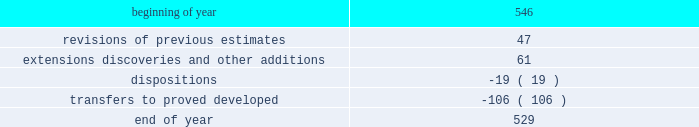Supplementary information on oil and gas producing activities ( unaudited ) 2018 proved reserves decreased by 168 mmboe primarily due to the following : 2022 revisions of previous estimates : increased by 84 mmboe including an increase of 108 mmboe associated with the acceleration of higher economic wells in the u.s .
Resource plays into the 5-year plan and an increase of 15 mmboe associated with wells to sales that were additions to the plan , partially offset by a decrease of 39 mmboe due to technical revisions across the business .
2022 extensions , discoveries , and other additions : increased by 102 mmboe primarily in the u.s .
Resource plays due to an increase of 69 mmboe associated with the expansion of proved areas and an increase of 33 mmboe associated with wells to sales from unproved categories .
2022 production : decreased by 153 mmboe .
2022 sales of reserves in place : decreased by 201 mmboe including 196 mmboe associated with the sale of our subsidiary in libya , 4 mmboe associated with divestitures of certain conventional assets in new mexico and michigan , and 1 mmboe associated with the sale of the sarsang block in kurdistan .
2017 proved reserves decreased by 647 mmboe primarily due to the following : 2022 revisions of previous estimates : increased by 49 mmboe primarily due to the acceleration of higher economic wells in the bakken into the 5-year plan resulting in an increase of 44 mmboe , with the remainder being due to revisions across the business .
2022 extensions , discoveries , and other additions : increased by 116 mmboe primarily due to an increase of 97 mmboe associated with the expansion of proved areas and wells to sales from unproved categories in oklahoma .
2022 purchases of reserves in place : increased by 28 mmboe from acquisitions of assets in the northern delaware basin in new mexico .
2022 production : decreased by 145 mmboe .
2022 sales of reserves in place : decreased by 695 mmboe including 685 mmboe associated with the sale of our canadian business and 10 mmboe associated with divestitures of certain conventional assets in oklahoma and colorado .
See item 8 .
Financial statements and supplementary data - note 5 to the consolidated financial statements for information regarding these dispositions .
2016 proved reserves decreased by 67 mmboe primarily due to the following : 2022 revisions of previous estimates : increased by 63 mmboe primarily due to an increase of 151 mmboe associated with the acceleration of higher economic wells in the u.s .
Resource plays into the 5-year plan and a decrease of 64 mmboe due to u.s .
Technical revisions .
2022 extensions , discoveries , and other additions : increased by 60 mmboe primarily associated with the expansion of proved areas and new wells to sales from unproven categories in oklahoma .
2022 purchases of reserves in place : increased by 34 mmboe from acquisition of stack assets in oklahoma .
2022 production : decreased by 144 mmboe .
2022 sales of reserves in place : decreased by 84 mmboe associated with the divestitures of certain wyoming and gulf of mexico assets .
Changes in proved undeveloped reserves as of december 31 , 2018 , 529 mmboe of proved undeveloped reserves were reported , a decrease of 17 mmboe from december 31 , 2017 .
The table shows changes in proved undeveloped reserves for 2018 : ( mmboe ) .

What was the net decrease in proved undeveloped reserves for 2018 : ( mmboe ) ? 
Computations: (529 - 546)
Answer: -17.0. 